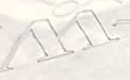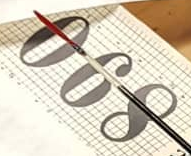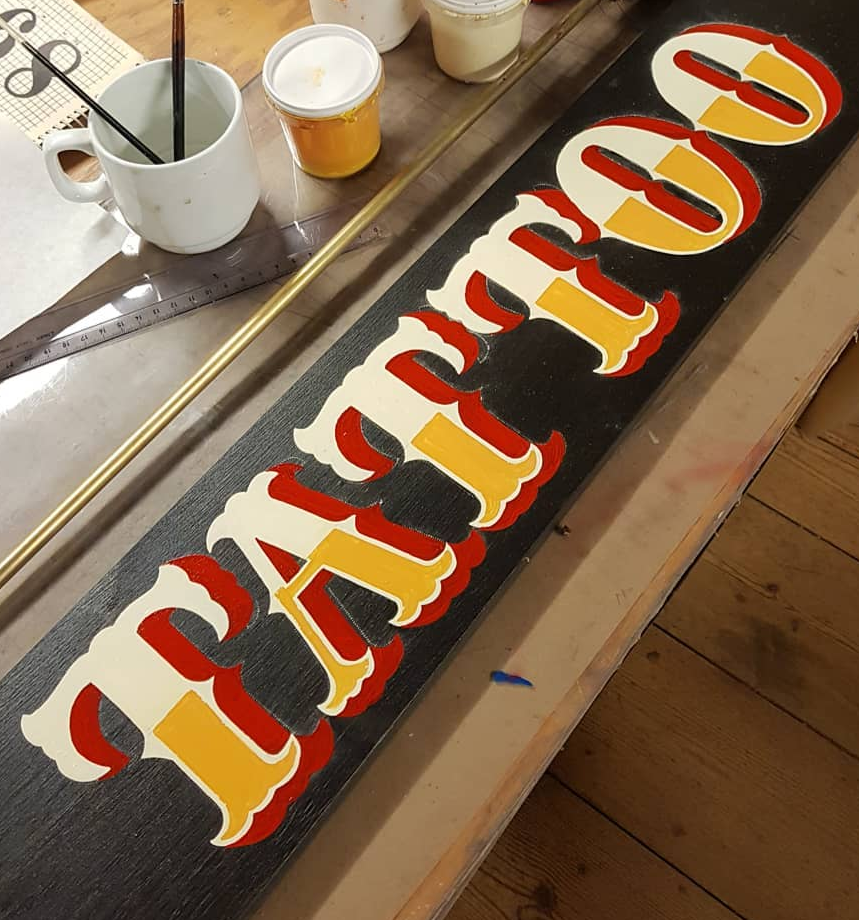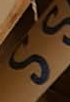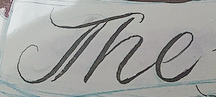What words are shown in these images in order, separated by a semicolon? W; 890; TATTOO; SS; The 